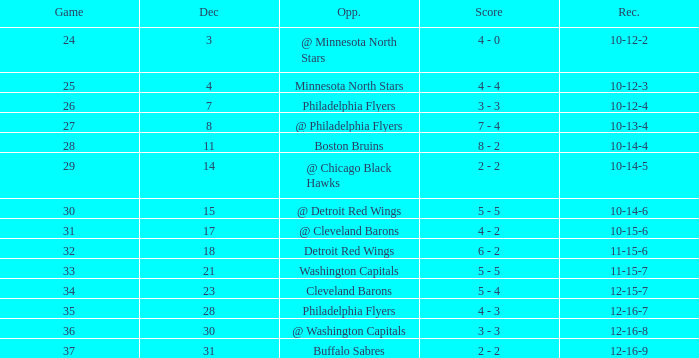What is Opponent, when Game is "37"? Buffalo Sabres. 